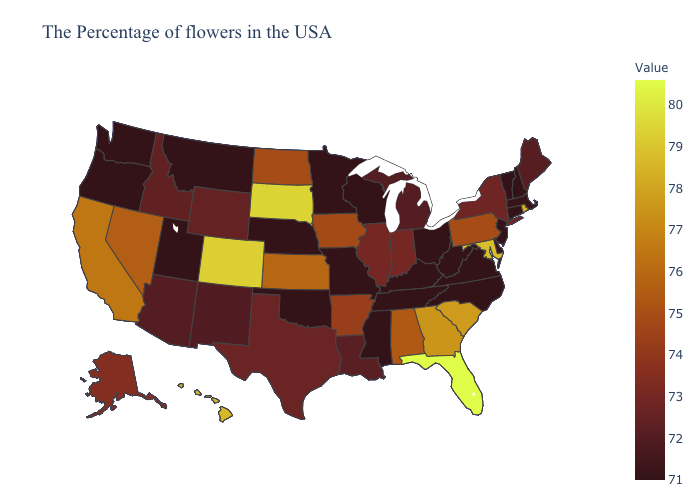Among the states that border Nevada , does Idaho have the lowest value?
Give a very brief answer. No. Does the map have missing data?
Quick response, please. No. 